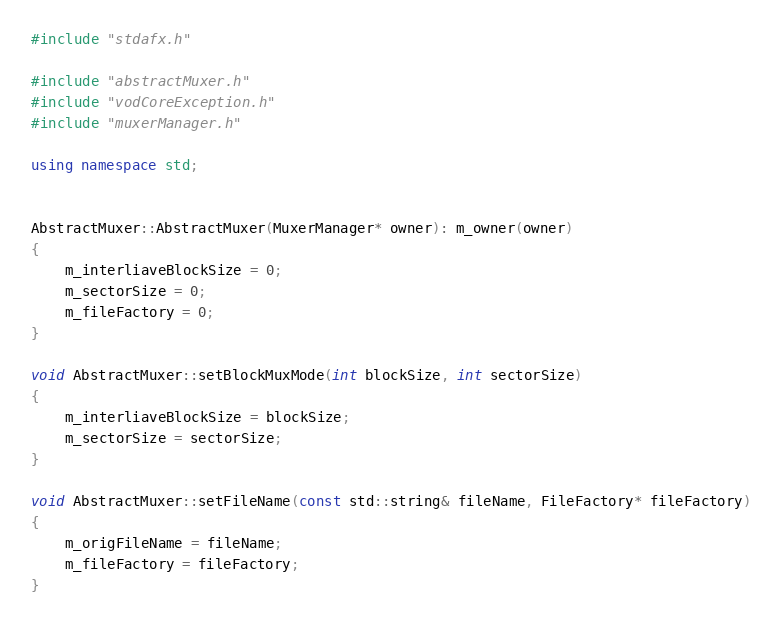Convert code to text. <code><loc_0><loc_0><loc_500><loc_500><_C++_>#include "stdafx.h"

#include "abstractMuxer.h"
#include "vodCoreException.h"
#include "muxerManager.h"

using namespace std;


AbstractMuxer::AbstractMuxer(MuxerManager* owner): m_owner(owner)
{
    m_interliaveBlockSize = 0;
    m_sectorSize = 0;
    m_fileFactory = 0;
}

void AbstractMuxer::setBlockMuxMode(int blockSize, int sectorSize) 
{ 
    m_interliaveBlockSize = blockSize; 
    m_sectorSize = sectorSize;
} 

void AbstractMuxer::setFileName(const std::string& fileName, FileFactory* fileFactory)
{ 
    m_origFileName = fileName;
    m_fileFactory = fileFactory;
}
</code> 